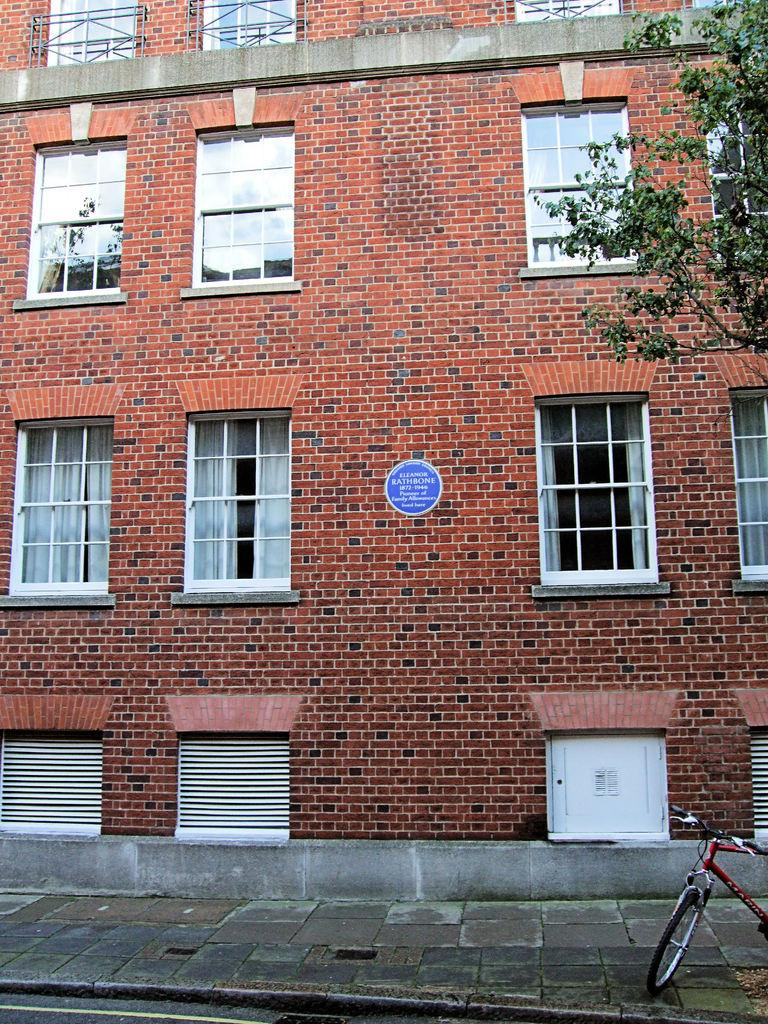What type of structure is visible in the image? There is a building in the image. What is the color of the building? The building is brown in color. What feature can be seen on the building? The building has windows. What is at the bottom of the image? There is a pavement at the bottom of the image. What object is present to the right of the image? There is a bicycle to the right of the image. What type of vegetation is also present to the right of the image? There is a tree to the right of the image. What type of hat is the butter wearing in the image? There is no hat or butter present in the image. 